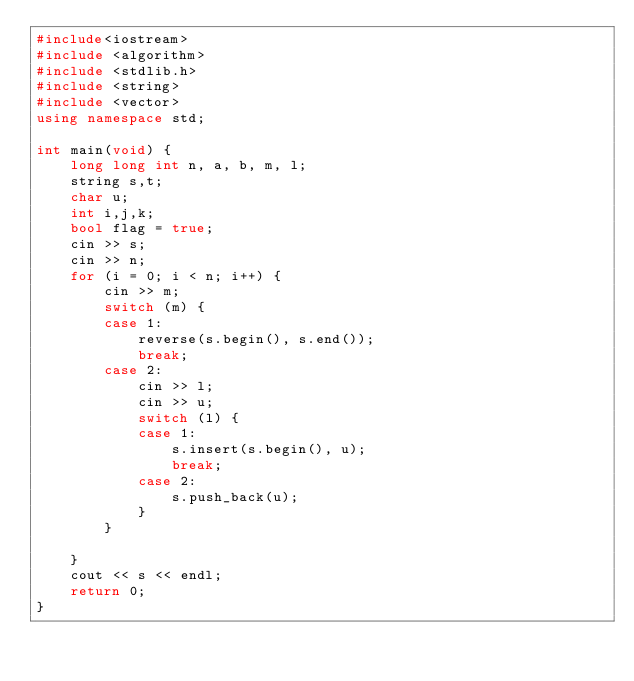<code> <loc_0><loc_0><loc_500><loc_500><_C++_>#include<iostream>
#include <algorithm>
#include <stdlib.h>
#include <string>
#include <vector>
using namespace std;

int main(void) {
	long long int n, a, b, m, l;
	string s,t;
	char u;
	int i,j,k;
	bool flag = true;
	cin >> s;
	cin >> n;
	for (i = 0; i < n; i++) {
		cin >> m;
		switch (m) {
		case 1:
			reverse(s.begin(), s.end());
			break;
		case 2:
			cin >> l;
			cin >> u;
			switch (l) {
			case 1:
				s.insert(s.begin(), u);
				break;
			case 2:
				s.push_back(u);
			}
		}
					
	}
	cout << s << endl;
	return 0;
}</code> 